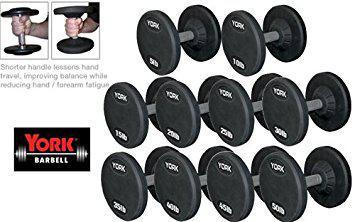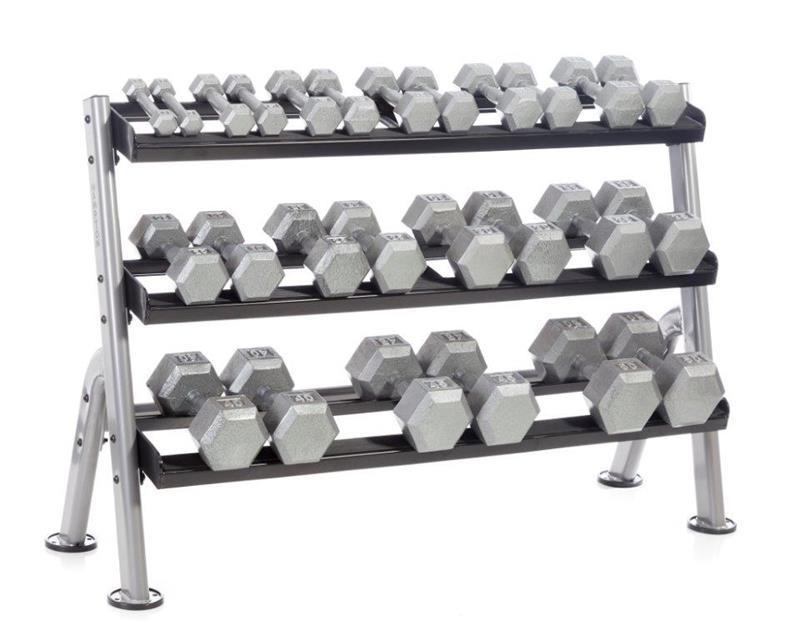The first image is the image on the left, the second image is the image on the right. Analyze the images presented: Is the assertion "An image features a three-tiered rack containing dumbbells with hexagon-shaped weights." valid? Answer yes or no. Yes. 